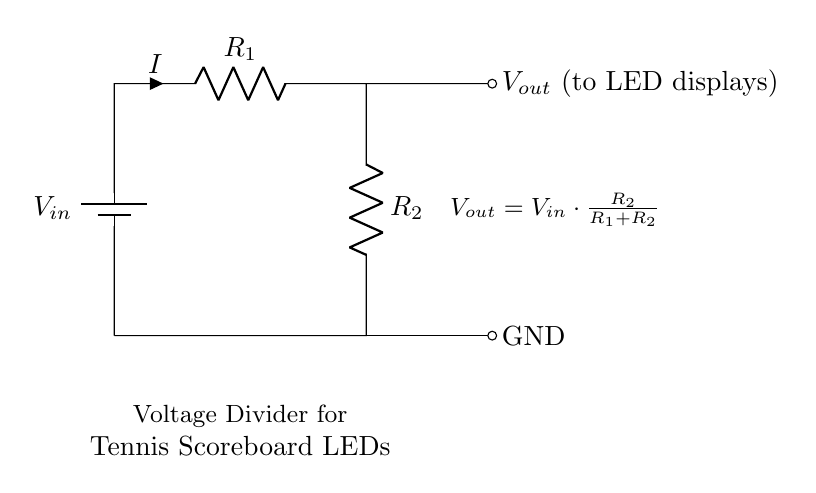What are the components used in the circuit? The circuit uses a battery, two resistors, and connections to LED displays and ground.
Answer: battery, resistors, LED displays What is the purpose of the resistors in the voltage divider? The resistors create a voltage drop, allowing part of the input voltage to be used to power the LED displays.
Answer: voltage drop What is the formula for the output voltage? The output voltage is given by the equation Vout = Vin * (R2 / (R1 + R2)), which shows how the voltage is divided based on the resistor values.
Answer: Vout = Vin * (R2 / (R1 + R2)) How do you calculate the total resistance in the voltage divider? The total resistance is the sum of the two resistors, R1 + R2, indicating how resistance affects current flow through the circuit.
Answer: R1 + R2 If R1 is twice the value of R2, what does the output voltage equal? With R1 being twice R2, the output voltage can be determined using the voltage divider formula, yielding one-third of the input voltage.
Answer: Vin / 3 What happens to the output voltage if R2 is increased? Increasing R2 results in a higher output voltage because it increases the voltage drop across R2 in the voltage divider configuration.
Answer: increases Why is this circuit suitable for LED displays? This circuit provides a stable lower voltage suitable for LEDs, enabling them to function safely without being damaged by higher voltages.
Answer: stable voltage 